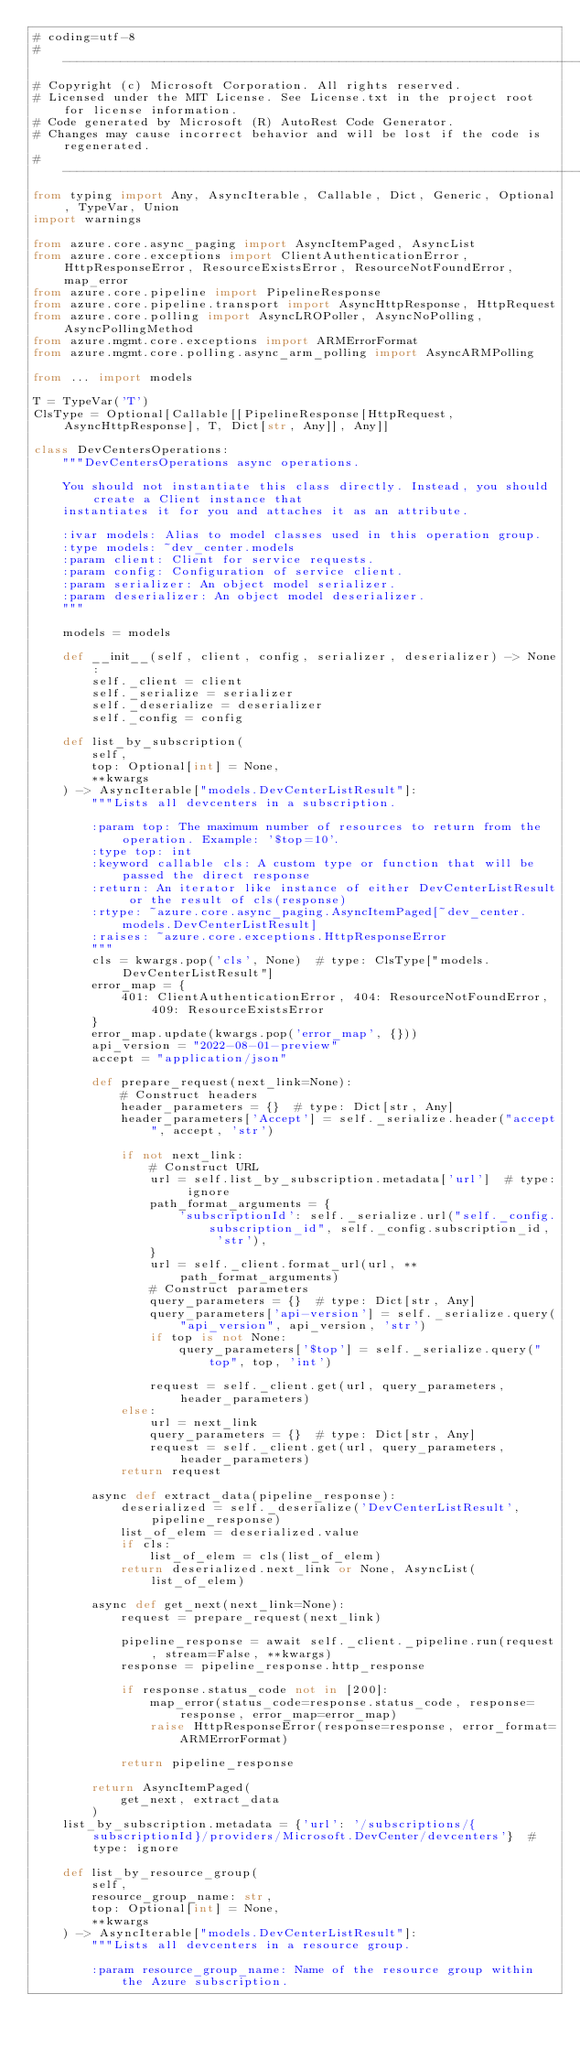Convert code to text. <code><loc_0><loc_0><loc_500><loc_500><_Python_># coding=utf-8
# --------------------------------------------------------------------------
# Copyright (c) Microsoft Corporation. All rights reserved.
# Licensed under the MIT License. See License.txt in the project root for license information.
# Code generated by Microsoft (R) AutoRest Code Generator.
# Changes may cause incorrect behavior and will be lost if the code is regenerated.
# --------------------------------------------------------------------------
from typing import Any, AsyncIterable, Callable, Dict, Generic, Optional, TypeVar, Union
import warnings

from azure.core.async_paging import AsyncItemPaged, AsyncList
from azure.core.exceptions import ClientAuthenticationError, HttpResponseError, ResourceExistsError, ResourceNotFoundError, map_error
from azure.core.pipeline import PipelineResponse
from azure.core.pipeline.transport import AsyncHttpResponse, HttpRequest
from azure.core.polling import AsyncLROPoller, AsyncNoPolling, AsyncPollingMethod
from azure.mgmt.core.exceptions import ARMErrorFormat
from azure.mgmt.core.polling.async_arm_polling import AsyncARMPolling

from ... import models

T = TypeVar('T')
ClsType = Optional[Callable[[PipelineResponse[HttpRequest, AsyncHttpResponse], T, Dict[str, Any]], Any]]

class DevCentersOperations:
    """DevCentersOperations async operations.

    You should not instantiate this class directly. Instead, you should create a Client instance that
    instantiates it for you and attaches it as an attribute.

    :ivar models: Alias to model classes used in this operation group.
    :type models: ~dev_center.models
    :param client: Client for service requests.
    :param config: Configuration of service client.
    :param serializer: An object model serializer.
    :param deserializer: An object model deserializer.
    """

    models = models

    def __init__(self, client, config, serializer, deserializer) -> None:
        self._client = client
        self._serialize = serializer
        self._deserialize = deserializer
        self._config = config

    def list_by_subscription(
        self,
        top: Optional[int] = None,
        **kwargs
    ) -> AsyncIterable["models.DevCenterListResult"]:
        """Lists all devcenters in a subscription.

        :param top: The maximum number of resources to return from the operation. Example: '$top=10'.
        :type top: int
        :keyword callable cls: A custom type or function that will be passed the direct response
        :return: An iterator like instance of either DevCenterListResult or the result of cls(response)
        :rtype: ~azure.core.async_paging.AsyncItemPaged[~dev_center.models.DevCenterListResult]
        :raises: ~azure.core.exceptions.HttpResponseError
        """
        cls = kwargs.pop('cls', None)  # type: ClsType["models.DevCenterListResult"]
        error_map = {
            401: ClientAuthenticationError, 404: ResourceNotFoundError, 409: ResourceExistsError
        }
        error_map.update(kwargs.pop('error_map', {}))
        api_version = "2022-08-01-preview"
        accept = "application/json"

        def prepare_request(next_link=None):
            # Construct headers
            header_parameters = {}  # type: Dict[str, Any]
            header_parameters['Accept'] = self._serialize.header("accept", accept, 'str')

            if not next_link:
                # Construct URL
                url = self.list_by_subscription.metadata['url']  # type: ignore
                path_format_arguments = {
                    'subscriptionId': self._serialize.url("self._config.subscription_id", self._config.subscription_id, 'str'),
                }
                url = self._client.format_url(url, **path_format_arguments)
                # Construct parameters
                query_parameters = {}  # type: Dict[str, Any]
                query_parameters['api-version'] = self._serialize.query("api_version", api_version, 'str')
                if top is not None:
                    query_parameters['$top'] = self._serialize.query("top", top, 'int')

                request = self._client.get(url, query_parameters, header_parameters)
            else:
                url = next_link
                query_parameters = {}  # type: Dict[str, Any]
                request = self._client.get(url, query_parameters, header_parameters)
            return request

        async def extract_data(pipeline_response):
            deserialized = self._deserialize('DevCenterListResult', pipeline_response)
            list_of_elem = deserialized.value
            if cls:
                list_of_elem = cls(list_of_elem)
            return deserialized.next_link or None, AsyncList(list_of_elem)

        async def get_next(next_link=None):
            request = prepare_request(next_link)

            pipeline_response = await self._client._pipeline.run(request, stream=False, **kwargs)
            response = pipeline_response.http_response

            if response.status_code not in [200]:
                map_error(status_code=response.status_code, response=response, error_map=error_map)
                raise HttpResponseError(response=response, error_format=ARMErrorFormat)

            return pipeline_response

        return AsyncItemPaged(
            get_next, extract_data
        )
    list_by_subscription.metadata = {'url': '/subscriptions/{subscriptionId}/providers/Microsoft.DevCenter/devcenters'}  # type: ignore

    def list_by_resource_group(
        self,
        resource_group_name: str,
        top: Optional[int] = None,
        **kwargs
    ) -> AsyncIterable["models.DevCenterListResult"]:
        """Lists all devcenters in a resource group.

        :param resource_group_name: Name of the resource group within the Azure subscription.</code> 